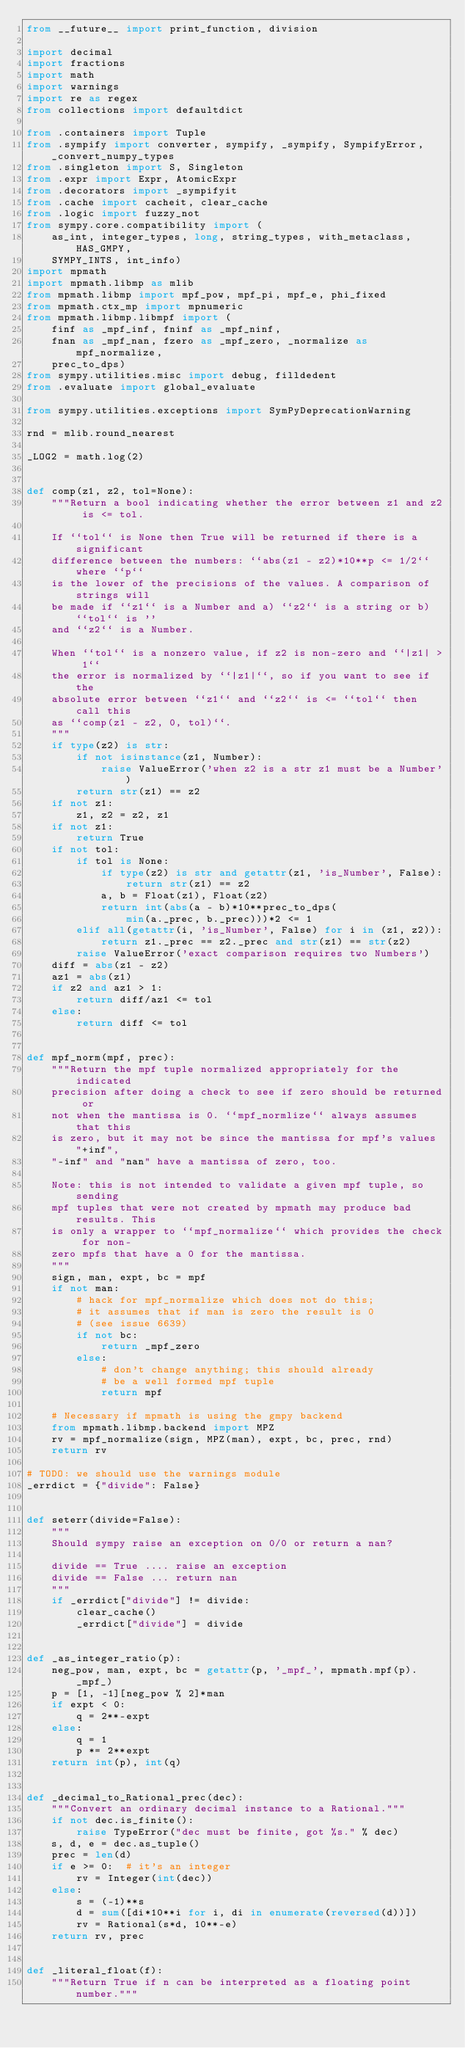Convert code to text. <code><loc_0><loc_0><loc_500><loc_500><_Python_>from __future__ import print_function, division

import decimal
import fractions
import math
import warnings
import re as regex
from collections import defaultdict

from .containers import Tuple
from .sympify import converter, sympify, _sympify, SympifyError, _convert_numpy_types
from .singleton import S, Singleton
from .expr import Expr, AtomicExpr
from .decorators import _sympifyit
from .cache import cacheit, clear_cache
from .logic import fuzzy_not
from sympy.core.compatibility import (
    as_int, integer_types, long, string_types, with_metaclass, HAS_GMPY,
    SYMPY_INTS, int_info)
import mpmath
import mpmath.libmp as mlib
from mpmath.libmp import mpf_pow, mpf_pi, mpf_e, phi_fixed
from mpmath.ctx_mp import mpnumeric
from mpmath.libmp.libmpf import (
    finf as _mpf_inf, fninf as _mpf_ninf,
    fnan as _mpf_nan, fzero as _mpf_zero, _normalize as mpf_normalize,
    prec_to_dps)
from sympy.utilities.misc import debug, filldedent
from .evaluate import global_evaluate

from sympy.utilities.exceptions import SymPyDeprecationWarning

rnd = mlib.round_nearest

_LOG2 = math.log(2)


def comp(z1, z2, tol=None):
    """Return a bool indicating whether the error between z1 and z2 is <= tol.

    If ``tol`` is None then True will be returned if there is a significant
    difference between the numbers: ``abs(z1 - z2)*10**p <= 1/2`` where ``p``
    is the lower of the precisions of the values. A comparison of strings will
    be made if ``z1`` is a Number and a) ``z2`` is a string or b) ``tol`` is ''
    and ``z2`` is a Number.

    When ``tol`` is a nonzero value, if z2 is non-zero and ``|z1| > 1``
    the error is normalized by ``|z1|``, so if you want to see if the
    absolute error between ``z1`` and ``z2`` is <= ``tol`` then call this
    as ``comp(z1 - z2, 0, tol)``.
    """
    if type(z2) is str:
        if not isinstance(z1, Number):
            raise ValueError('when z2 is a str z1 must be a Number')
        return str(z1) == z2
    if not z1:
        z1, z2 = z2, z1
    if not z1:
        return True
    if not tol:
        if tol is None:
            if type(z2) is str and getattr(z1, 'is_Number', False):
                return str(z1) == z2
            a, b = Float(z1), Float(z2)
            return int(abs(a - b)*10**prec_to_dps(
                min(a._prec, b._prec)))*2 <= 1
        elif all(getattr(i, 'is_Number', False) for i in (z1, z2)):
            return z1._prec == z2._prec and str(z1) == str(z2)
        raise ValueError('exact comparison requires two Numbers')
    diff = abs(z1 - z2)
    az1 = abs(z1)
    if z2 and az1 > 1:
        return diff/az1 <= tol
    else:
        return diff <= tol


def mpf_norm(mpf, prec):
    """Return the mpf tuple normalized appropriately for the indicated
    precision after doing a check to see if zero should be returned or
    not when the mantissa is 0. ``mpf_normlize`` always assumes that this
    is zero, but it may not be since the mantissa for mpf's values "+inf",
    "-inf" and "nan" have a mantissa of zero, too.

    Note: this is not intended to validate a given mpf tuple, so sending
    mpf tuples that were not created by mpmath may produce bad results. This
    is only a wrapper to ``mpf_normalize`` which provides the check for non-
    zero mpfs that have a 0 for the mantissa.
    """
    sign, man, expt, bc = mpf
    if not man:
        # hack for mpf_normalize which does not do this;
        # it assumes that if man is zero the result is 0
        # (see issue 6639)
        if not bc:
            return _mpf_zero
        else:
            # don't change anything; this should already
            # be a well formed mpf tuple
            return mpf

    # Necessary if mpmath is using the gmpy backend
    from mpmath.libmp.backend import MPZ
    rv = mpf_normalize(sign, MPZ(man), expt, bc, prec, rnd)
    return rv

# TODO: we should use the warnings module
_errdict = {"divide": False}


def seterr(divide=False):
    """
    Should sympy raise an exception on 0/0 or return a nan?

    divide == True .... raise an exception
    divide == False ... return nan
    """
    if _errdict["divide"] != divide:
        clear_cache()
        _errdict["divide"] = divide


def _as_integer_ratio(p):
    neg_pow, man, expt, bc = getattr(p, '_mpf_', mpmath.mpf(p)._mpf_)
    p = [1, -1][neg_pow % 2]*man
    if expt < 0:
        q = 2**-expt
    else:
        q = 1
        p *= 2**expt
    return int(p), int(q)


def _decimal_to_Rational_prec(dec):
    """Convert an ordinary decimal instance to a Rational."""
    if not dec.is_finite():
        raise TypeError("dec must be finite, got %s." % dec)
    s, d, e = dec.as_tuple()
    prec = len(d)
    if e >= 0:  # it's an integer
        rv = Integer(int(dec))
    else:
        s = (-1)**s
        d = sum([di*10**i for i, di in enumerate(reversed(d))])
        rv = Rational(s*d, 10**-e)
    return rv, prec


def _literal_float(f):
    """Return True if n can be interpreted as a floating point number."""</code> 